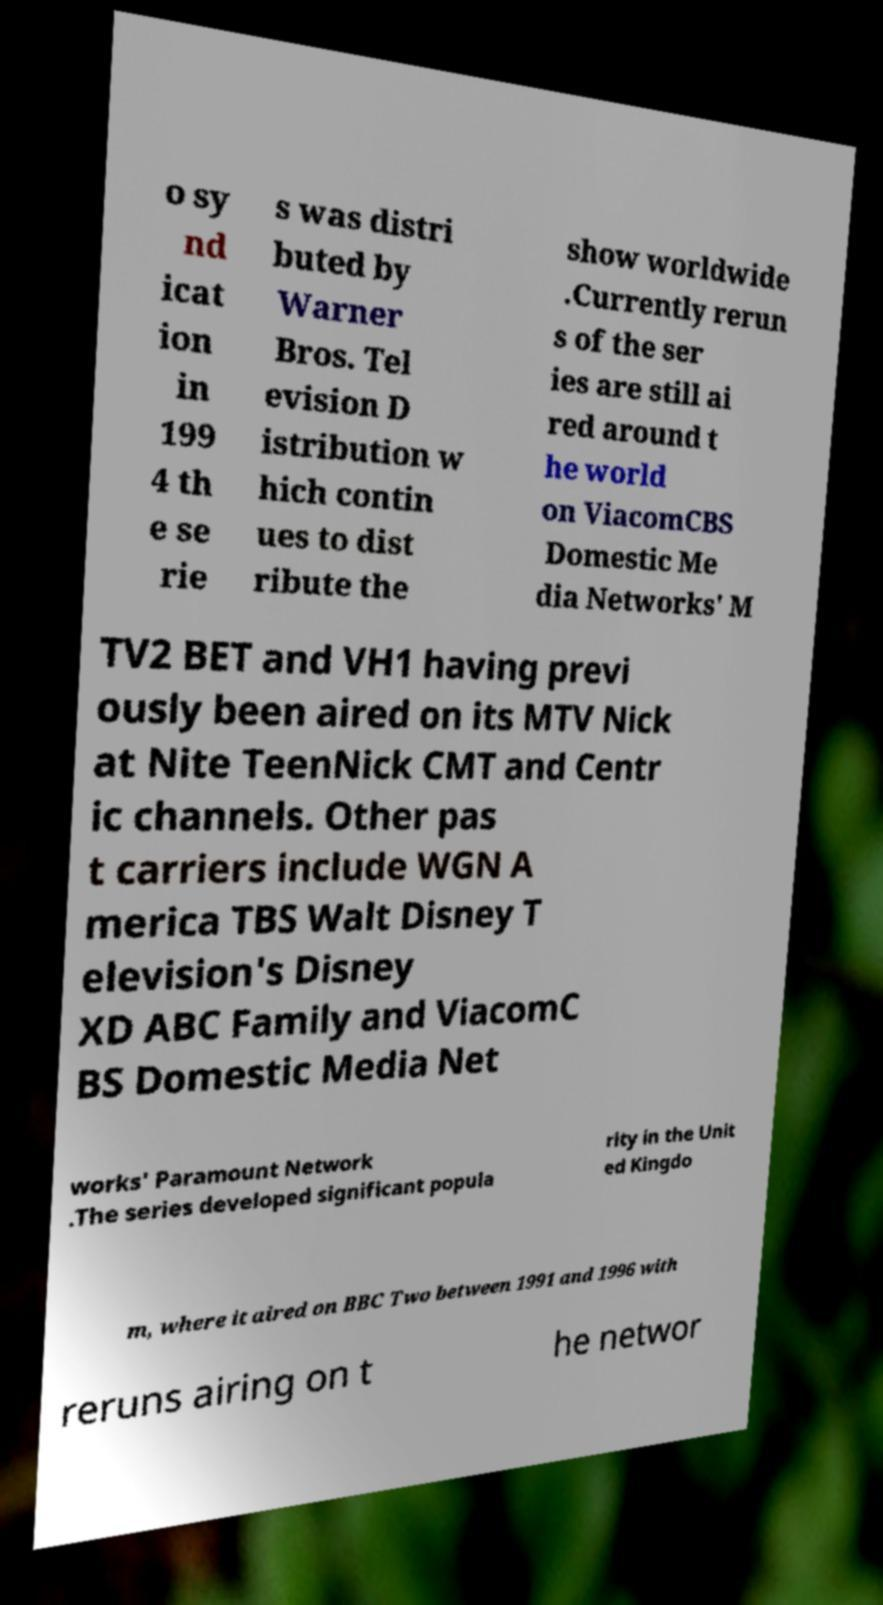What messages or text are displayed in this image? I need them in a readable, typed format. o sy nd icat ion in 199 4 th e se rie s was distri buted by Warner Bros. Tel evision D istribution w hich contin ues to dist ribute the show worldwide .Currently rerun s of the ser ies are still ai red around t he world on ViacomCBS Domestic Me dia Networks' M TV2 BET and VH1 having previ ously been aired on its MTV Nick at Nite TeenNick CMT and Centr ic channels. Other pas t carriers include WGN A merica TBS Walt Disney T elevision's Disney XD ABC Family and ViacomC BS Domestic Media Net works' Paramount Network .The series developed significant popula rity in the Unit ed Kingdo m, where it aired on BBC Two between 1991 and 1996 with reruns airing on t he networ 